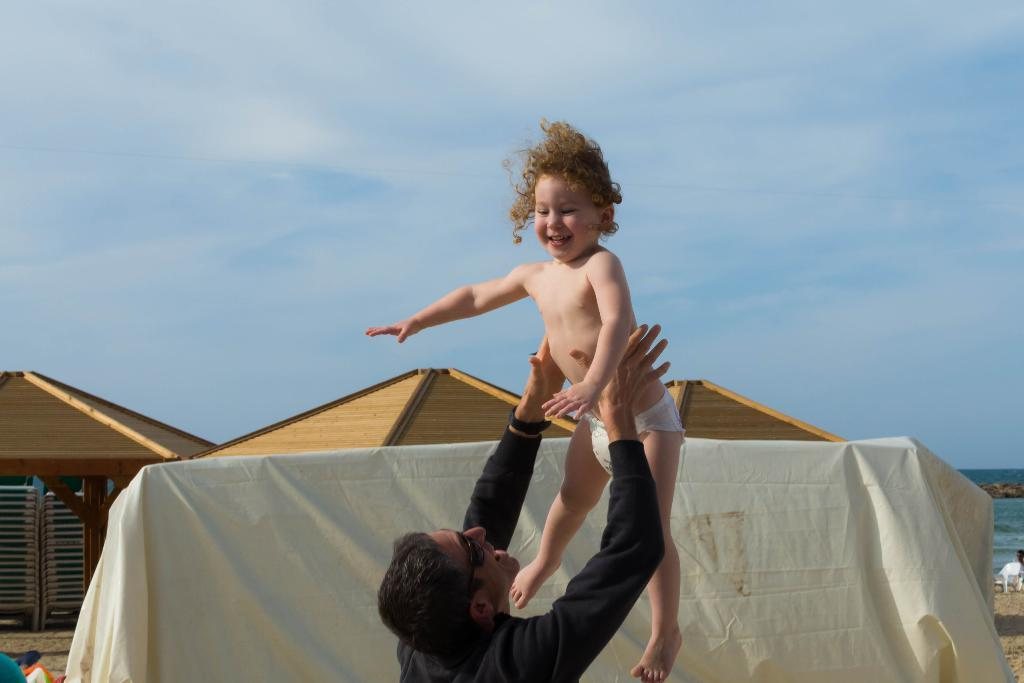What is the main subject of the image? There is a kid in the air in the image. What is the person wearing in the image? There is a person wearing a black dress in the image. What is the person doing with the kid? The person is holding the kid. What can be seen in the background of the image? There are other objects in the background of the image. What type of fruit is being used as a memory aid in the image? There is no fruit or memory aid present in the image. What is the purpose of the tub in the image? There is no tub present in the image. 